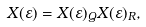Convert formula to latex. <formula><loc_0><loc_0><loc_500><loc_500>X ( \varepsilon ) = X ( \varepsilon ) _ { Q } X ( \varepsilon ) _ { R } ,</formula> 